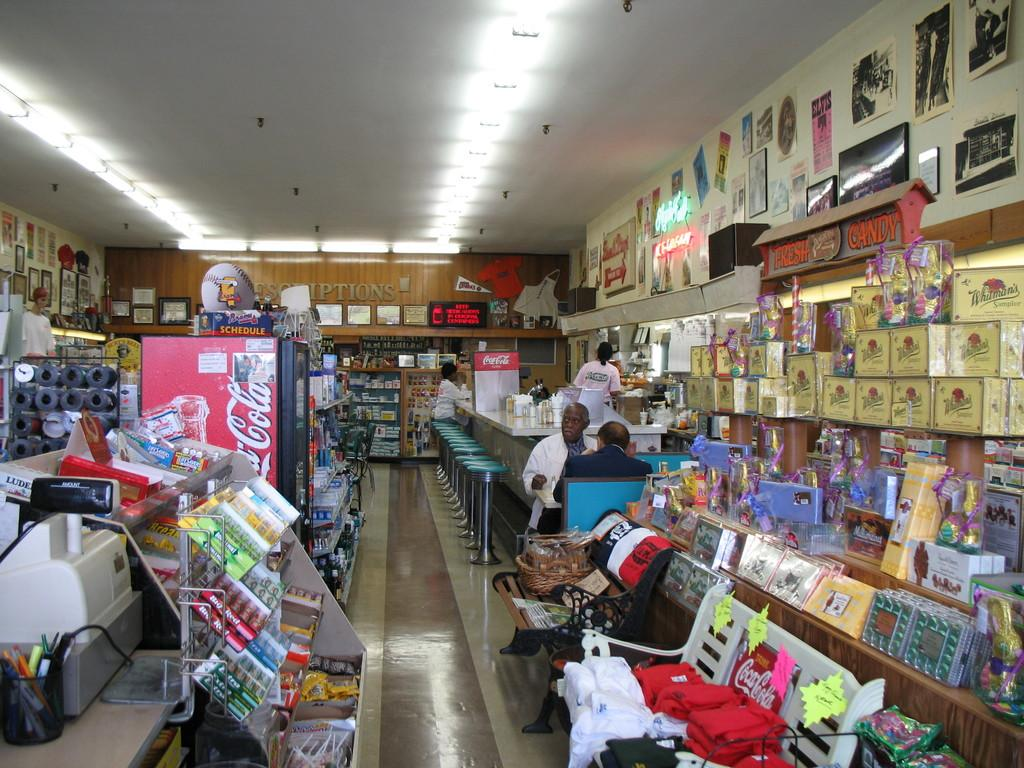<image>
Render a clear and concise summary of the photo. People inside a store with a freezer selling Coca Cola. 